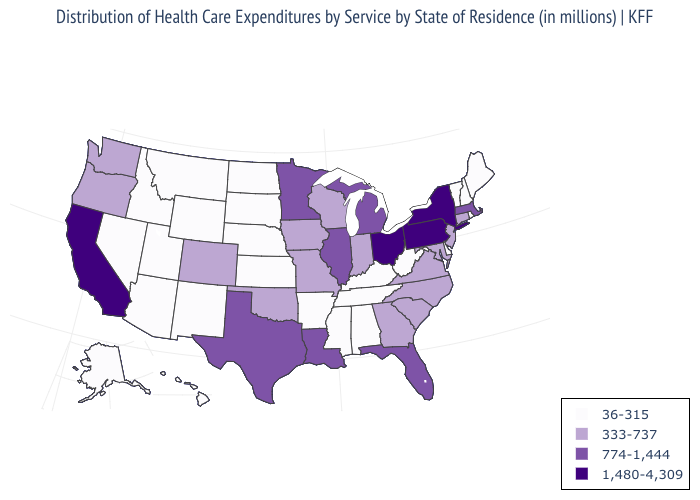Name the states that have a value in the range 333-737?
Answer briefly. Colorado, Connecticut, Georgia, Indiana, Iowa, Maryland, Missouri, New Jersey, North Carolina, Oklahoma, Oregon, South Carolina, Virginia, Washington, Wisconsin. Does the map have missing data?
Give a very brief answer. No. Name the states that have a value in the range 774-1,444?
Write a very short answer. Florida, Illinois, Louisiana, Massachusetts, Michigan, Minnesota, Texas. Does Maine have the lowest value in the USA?
Give a very brief answer. Yes. Does North Dakota have a lower value than New Hampshire?
Short answer required. No. What is the lowest value in states that border Maine?
Be succinct. 36-315. Name the states that have a value in the range 774-1,444?
Concise answer only. Florida, Illinois, Louisiana, Massachusetts, Michigan, Minnesota, Texas. What is the value of Connecticut?
Answer briefly. 333-737. What is the value of Missouri?
Write a very short answer. 333-737. What is the value of Arkansas?
Write a very short answer. 36-315. What is the value of Alaska?
Write a very short answer. 36-315. Name the states that have a value in the range 774-1,444?
Answer briefly. Florida, Illinois, Louisiana, Massachusetts, Michigan, Minnesota, Texas. Among the states that border Alabama , does Georgia have the lowest value?
Short answer required. No. Which states hav the highest value in the MidWest?
Be succinct. Ohio. What is the value of Florida?
Keep it brief. 774-1,444. 